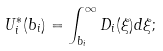<formula> <loc_0><loc_0><loc_500><loc_500>U ^ { * } _ { i } ( b _ { i } ) = \int _ { b _ { i } } ^ { \infty } D _ { i } ( \xi ) d \xi ;</formula> 